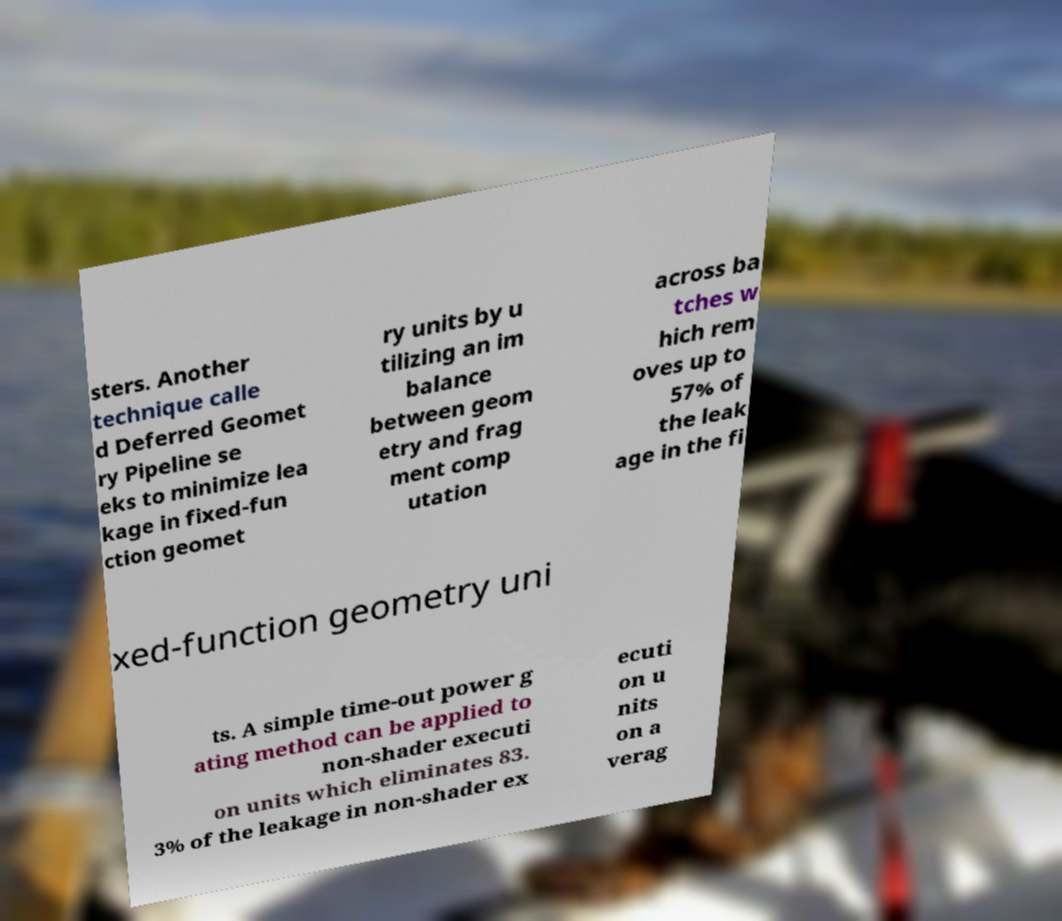Could you extract and type out the text from this image? sters. Another technique calle d Deferred Geomet ry Pipeline se eks to minimize lea kage in fixed-fun ction geomet ry units by u tilizing an im balance between geom etry and frag ment comp utation across ba tches w hich rem oves up to 57% of the leak age in the fi xed-function geometry uni ts. A simple time-out power g ating method can be applied to non-shader executi on units which eliminates 83. 3% of the leakage in non-shader ex ecuti on u nits on a verag 